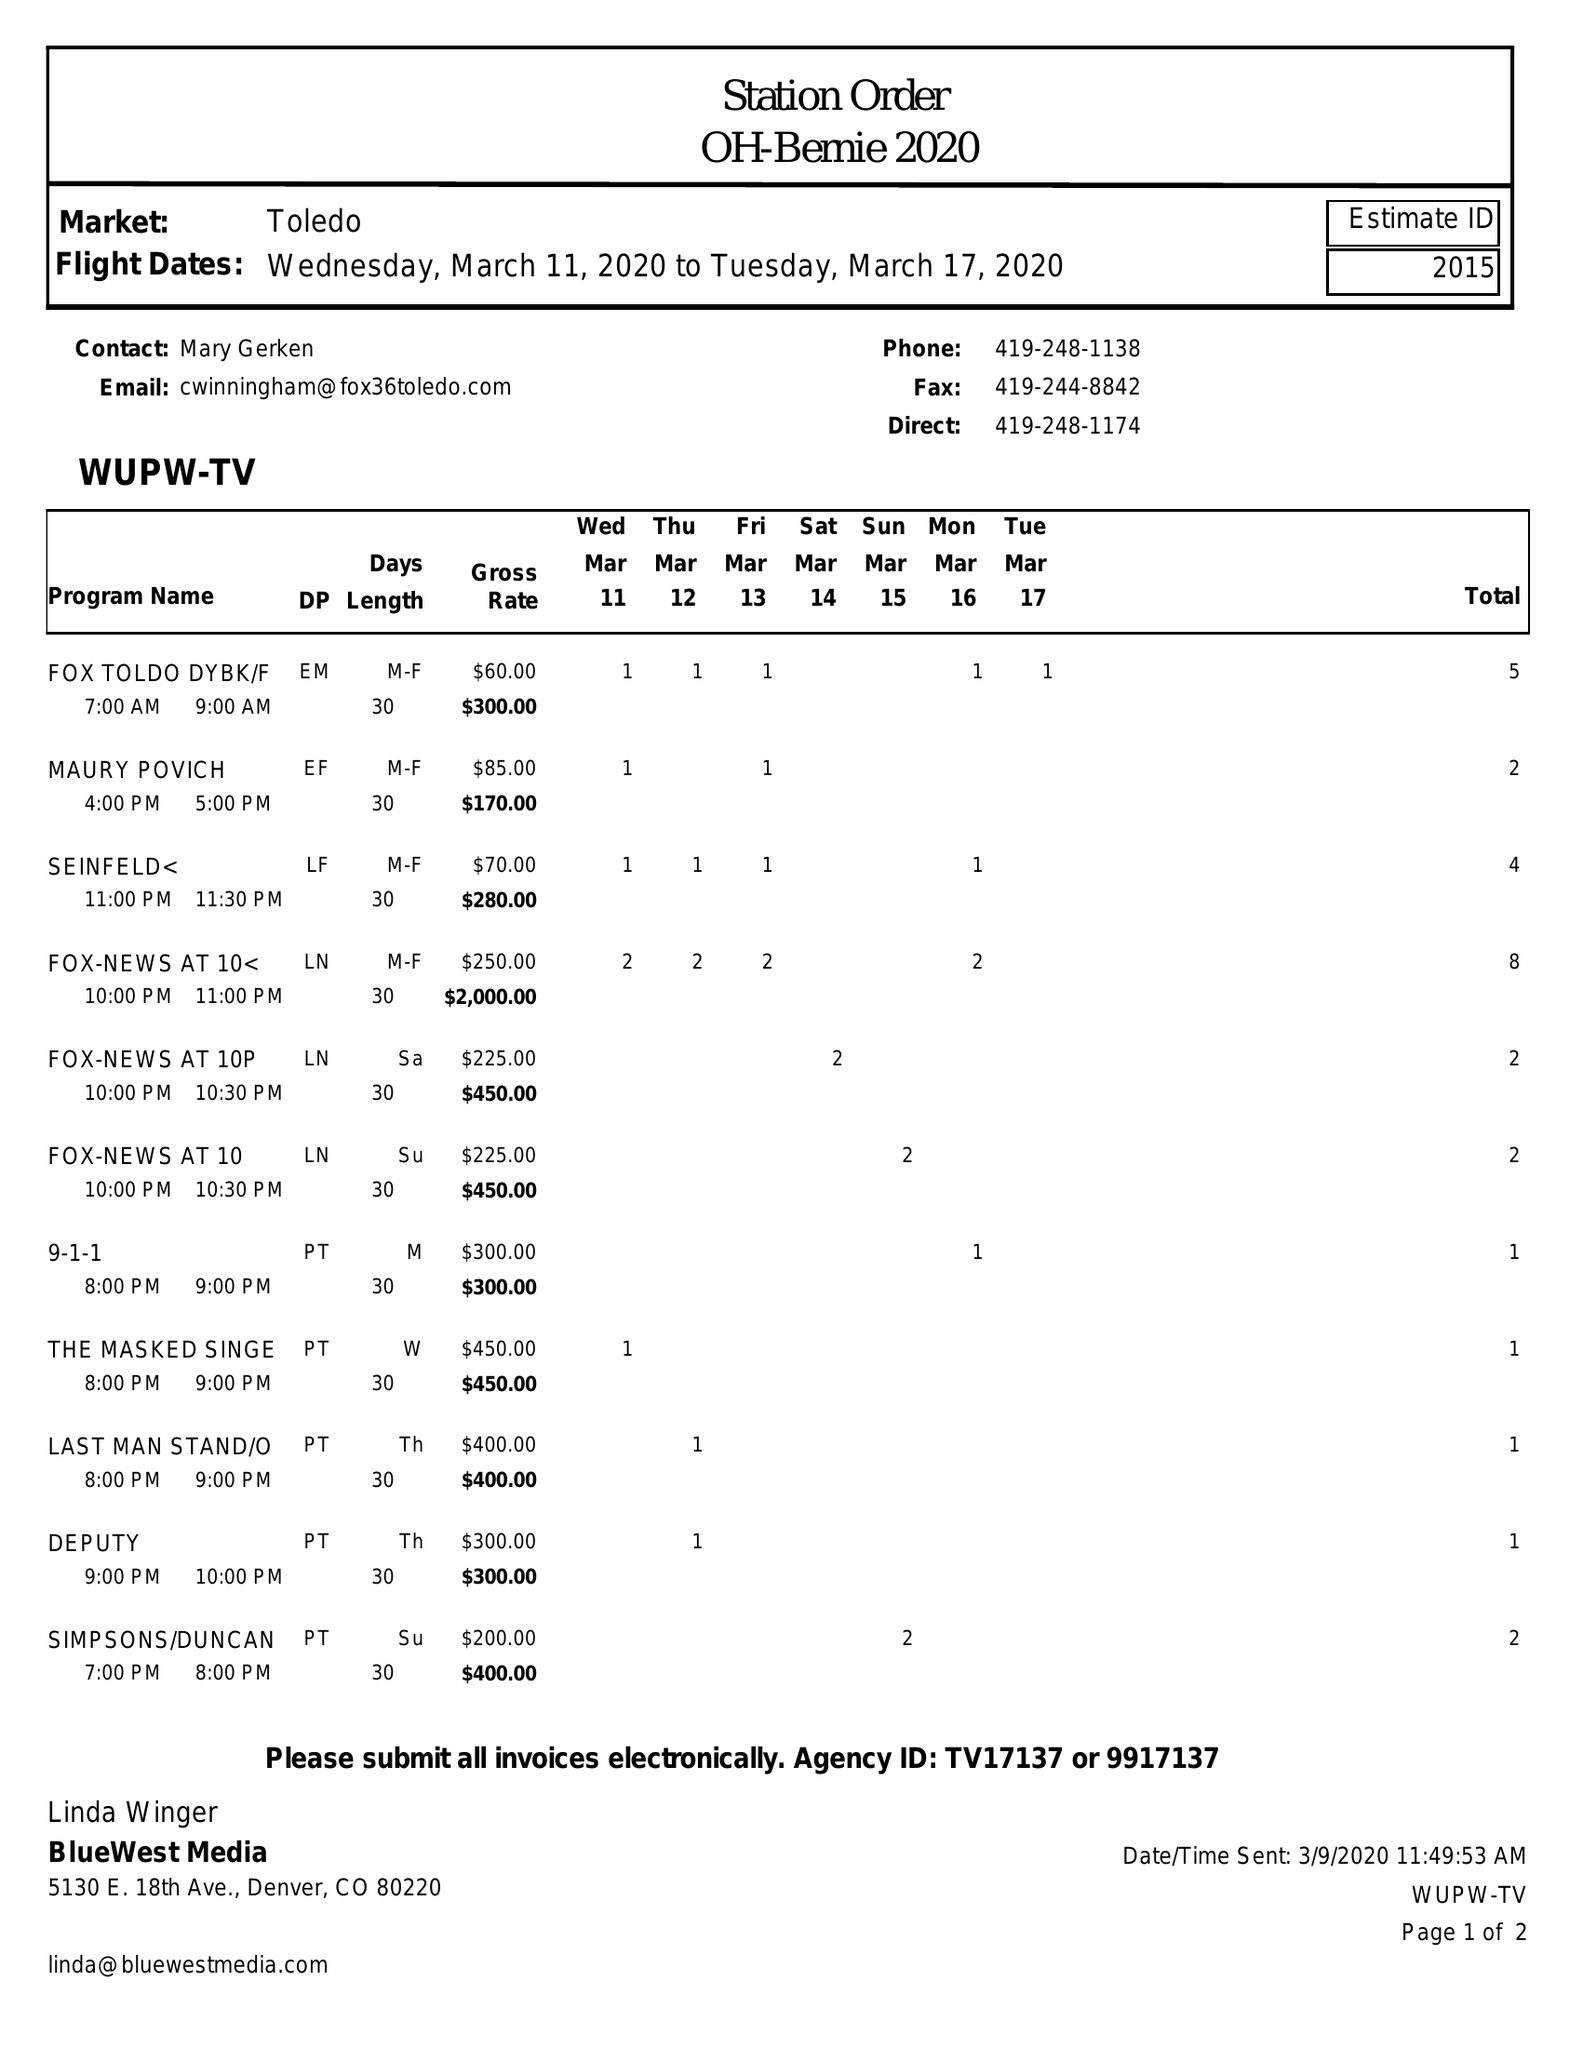What is the value for the flight_to?
Answer the question using a single word or phrase. 03/17/20 